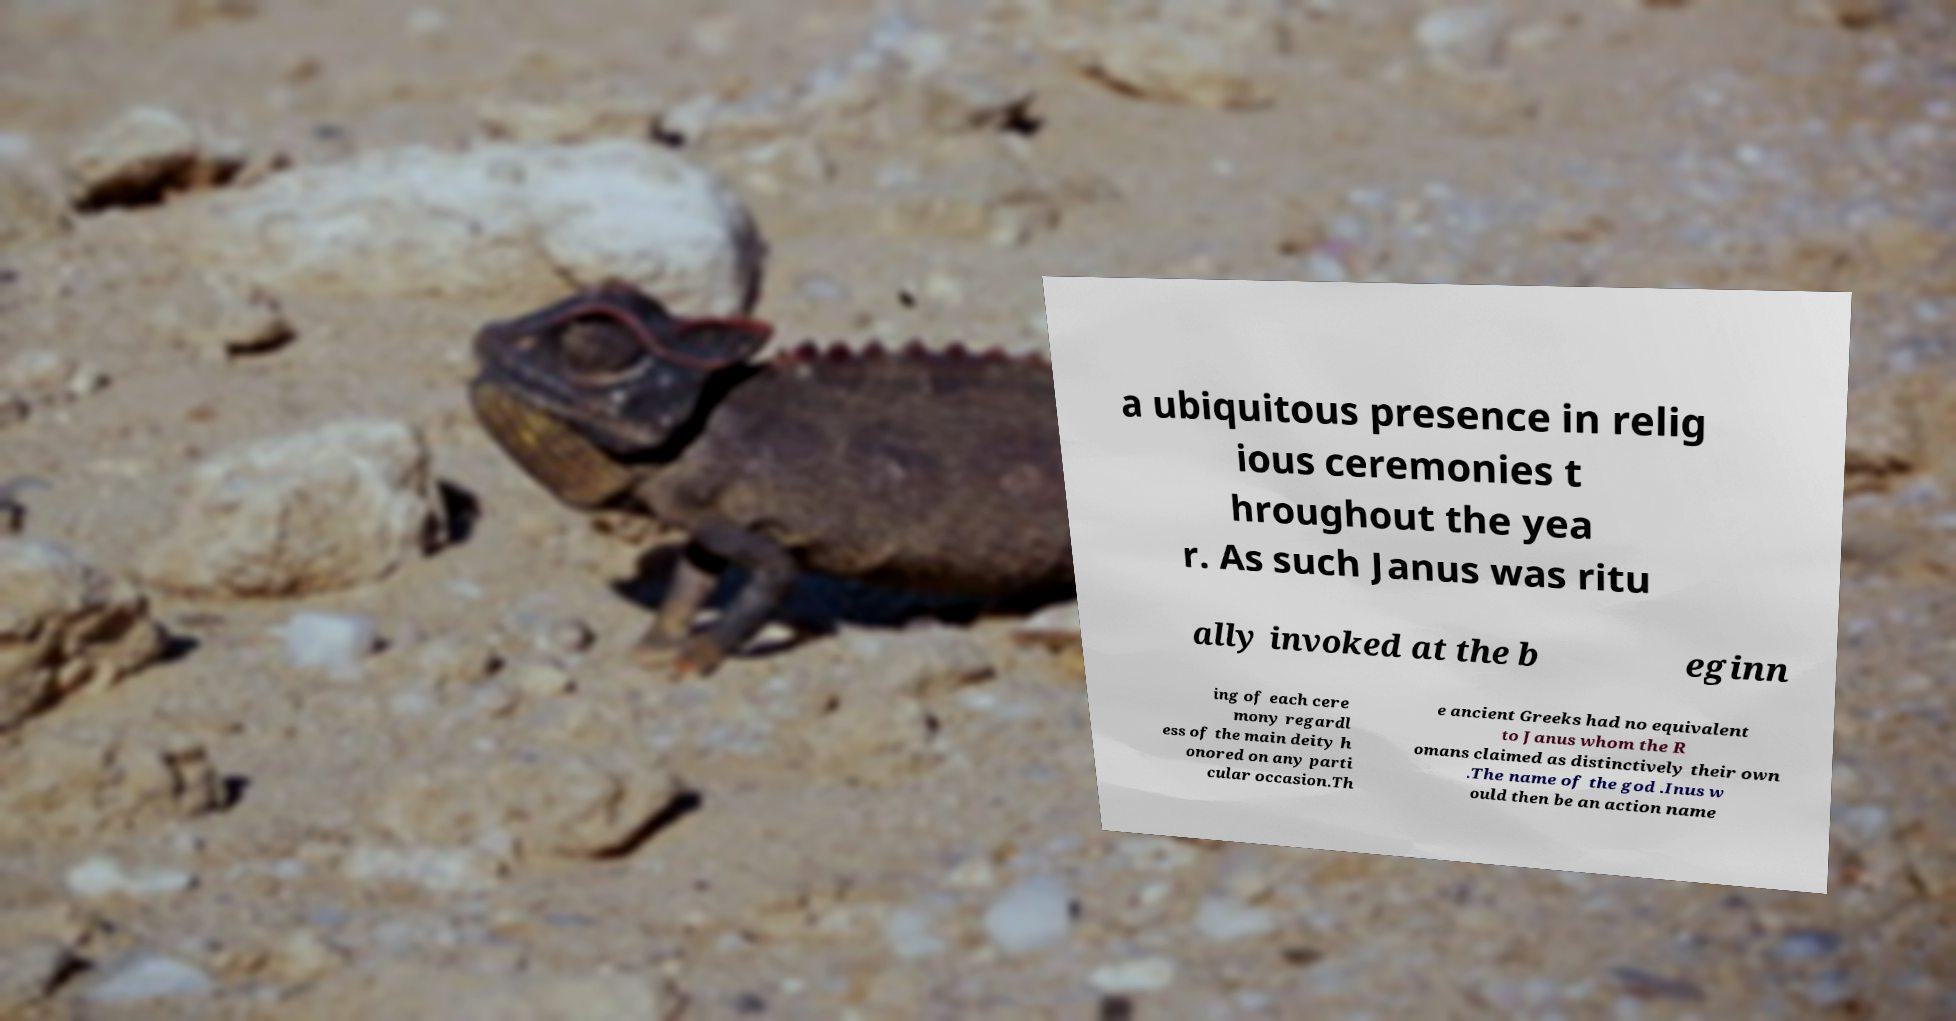There's text embedded in this image that I need extracted. Can you transcribe it verbatim? a ubiquitous presence in relig ious ceremonies t hroughout the yea r. As such Janus was ritu ally invoked at the b eginn ing of each cere mony regardl ess of the main deity h onored on any parti cular occasion.Th e ancient Greeks had no equivalent to Janus whom the R omans claimed as distinctively their own .The name of the god .Inus w ould then be an action name 